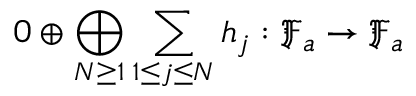Convert formula to latex. <formula><loc_0><loc_0><loc_500><loc_500>0 \oplus \bigoplus _ { N \geq 1 } \sum _ { 1 \leq j \leq N } h _ { j } \colon \mathfrak { F } _ { a } \to \mathfrak { F } _ { a }</formula> 